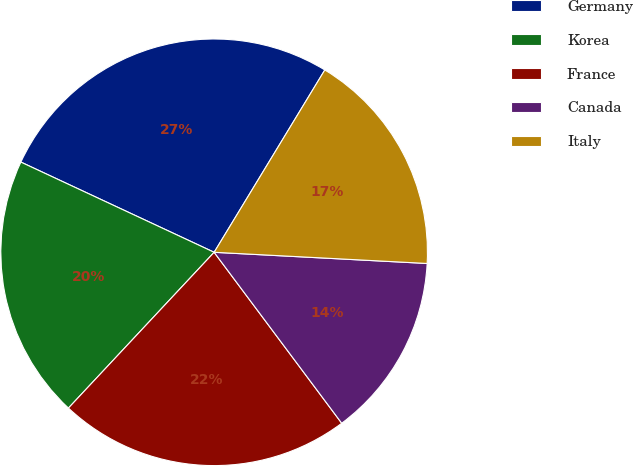Convert chart. <chart><loc_0><loc_0><loc_500><loc_500><pie_chart><fcel>Germany<fcel>Korea<fcel>France<fcel>Canada<fcel>Italy<nl><fcel>26.73%<fcel>19.98%<fcel>22.17%<fcel>13.96%<fcel>17.15%<nl></chart> 